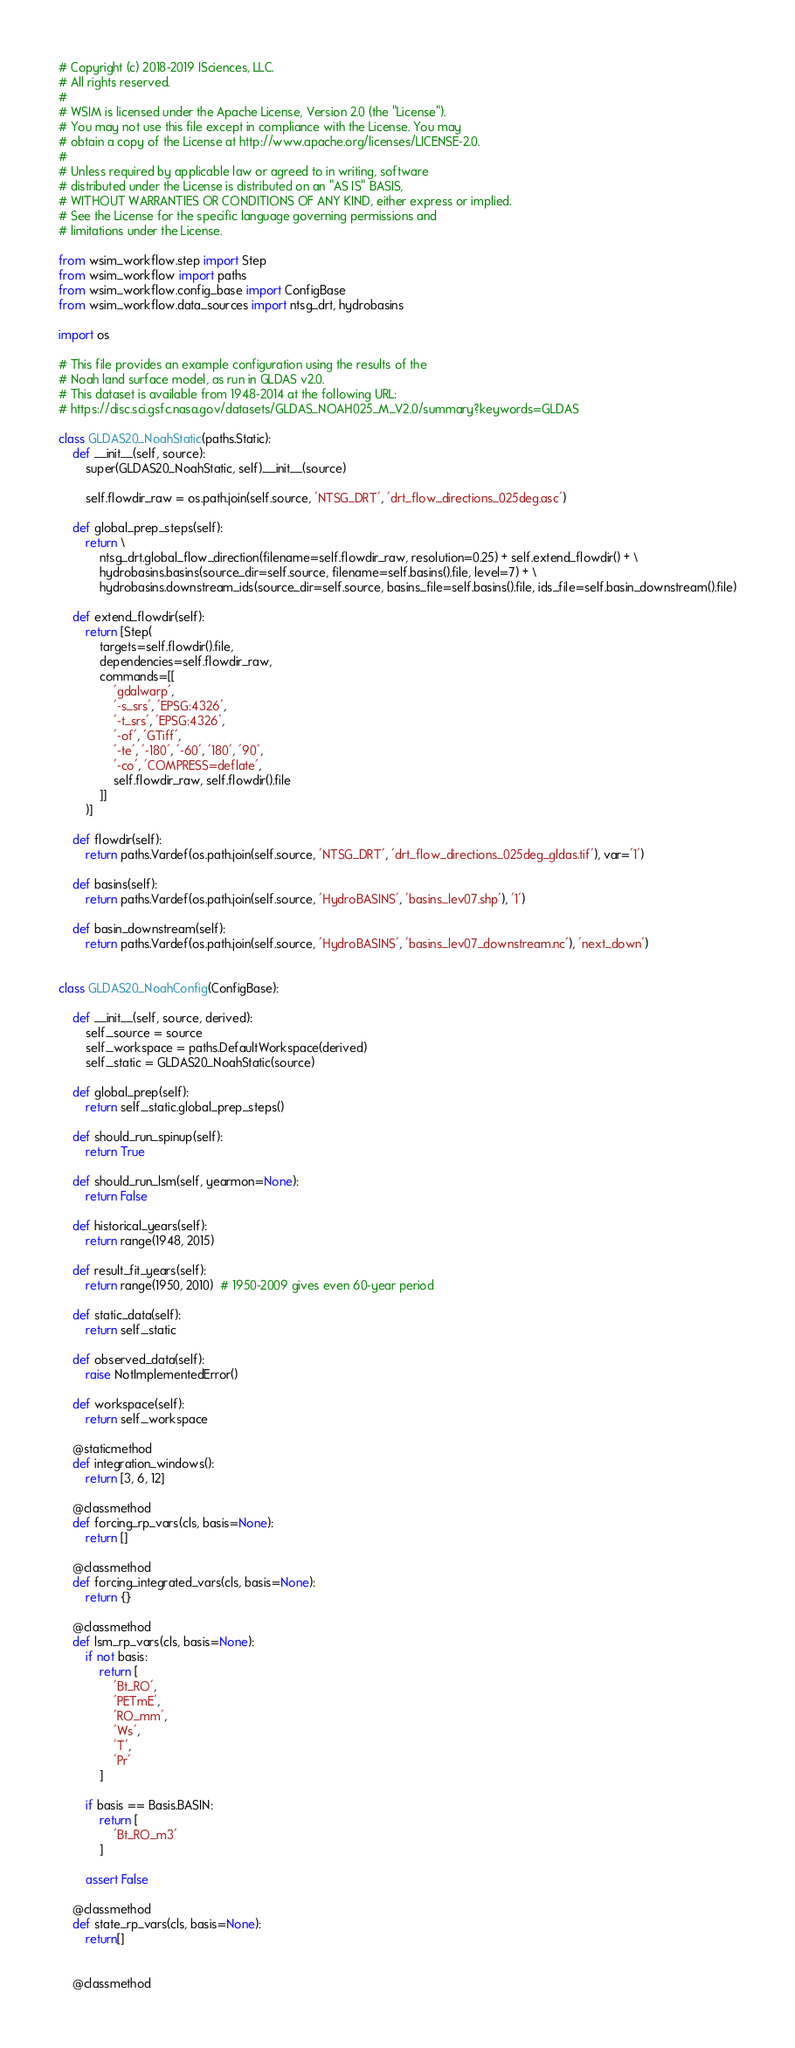Convert code to text. <code><loc_0><loc_0><loc_500><loc_500><_Python_># Copyright (c) 2018-2019 ISciences, LLC.
# All rights reserved.
#
# WSIM is licensed under the Apache License, Version 2.0 (the "License").
# You may not use this file except in compliance with the License. You may
# obtain a copy of the License at http://www.apache.org/licenses/LICENSE-2.0.
#
# Unless required by applicable law or agreed to in writing, software
# distributed under the License is distributed on an "AS IS" BASIS,
# WITHOUT WARRANTIES OR CONDITIONS OF ANY KIND, either express or implied.
# See the License for the specific language governing permissions and
# limitations under the License.

from wsim_workflow.step import Step
from wsim_workflow import paths
from wsim_workflow.config_base import ConfigBase
from wsim_workflow.data_sources import ntsg_drt, hydrobasins

import os

# This file provides an example configuration using the results of the
# Noah land surface model, as run in GLDAS v2.0.
# This dataset is available from 1948-2014 at the following URL:
# https://disc.sci.gsfc.nasa.gov/datasets/GLDAS_NOAH025_M_V2.0/summary?keywords=GLDAS

class GLDAS20_NoahStatic(paths.Static):
    def __init__(self, source):
        super(GLDAS20_NoahStatic, self).__init__(source)

        self.flowdir_raw = os.path.join(self.source, 'NTSG_DRT', 'drt_flow_directions_025deg.asc')

    def global_prep_steps(self):
        return \
            ntsg_drt.global_flow_direction(filename=self.flowdir_raw, resolution=0.25) + self.extend_flowdir() + \
            hydrobasins.basins(source_dir=self.source, filename=self.basins().file, level=7) + \
            hydrobasins.downstream_ids(source_dir=self.source, basins_file=self.basins().file, ids_file=self.basin_downstream().file)

    def extend_flowdir(self):
        return [Step(
            targets=self.flowdir().file,
            dependencies=self.flowdir_raw,
            commands=[[
                'gdalwarp',
                '-s_srs', 'EPSG:4326',
                '-t_srs', 'EPSG:4326',
                '-of', 'GTiff',
                '-te', '-180', '-60', '180', '90',
                '-co', 'COMPRESS=deflate',
                self.flowdir_raw, self.flowdir().file
            ]]
        )]

    def flowdir(self):
        return paths.Vardef(os.path.join(self.source, 'NTSG_DRT', 'drt_flow_directions_025deg_gldas.tif'), var='1')

    def basins(self):
        return paths.Vardef(os.path.join(self.source, 'HydroBASINS', 'basins_lev07.shp'), '1')

    def basin_downstream(self):
        return paths.Vardef(os.path.join(self.source, 'HydroBASINS', 'basins_lev07_downstream.nc'), 'next_down')


class GLDAS20_NoahConfig(ConfigBase):

    def __init__(self, source, derived):
        self._source = source
        self._workspace = paths.DefaultWorkspace(derived)
        self._static = GLDAS20_NoahStatic(source)

    def global_prep(self):
        return self._static.global_prep_steps()

    def should_run_spinup(self):
        return True

    def should_run_lsm(self, yearmon=None):
        return False

    def historical_years(self):
        return range(1948, 2015)

    def result_fit_years(self):
        return range(1950, 2010)  # 1950-2009 gives even 60-year period

    def static_data(self):
        return self._static

    def observed_data(self):
        raise NotImplementedError()

    def workspace(self):
        return self._workspace

    @staticmethod
    def integration_windows():
        return [3, 6, 12]

    @classmethod
    def forcing_rp_vars(cls, basis=None):
        return []

    @classmethod
    def forcing_integrated_vars(cls, basis=None):
        return {}

    @classmethod
    def lsm_rp_vars(cls, basis=None):
        if not basis:
            return [
                'Bt_RO',
                'PETmE',
                'RO_mm',
                'Ws',
                'T',
                'Pr'
            ]

        if basis == Basis.BASIN:
            return [
                'Bt_RO_m3'
            ]

        assert False

    @classmethod
    def state_rp_vars(cls, basis=None):
        return[]
        
        
    @classmethod</code> 